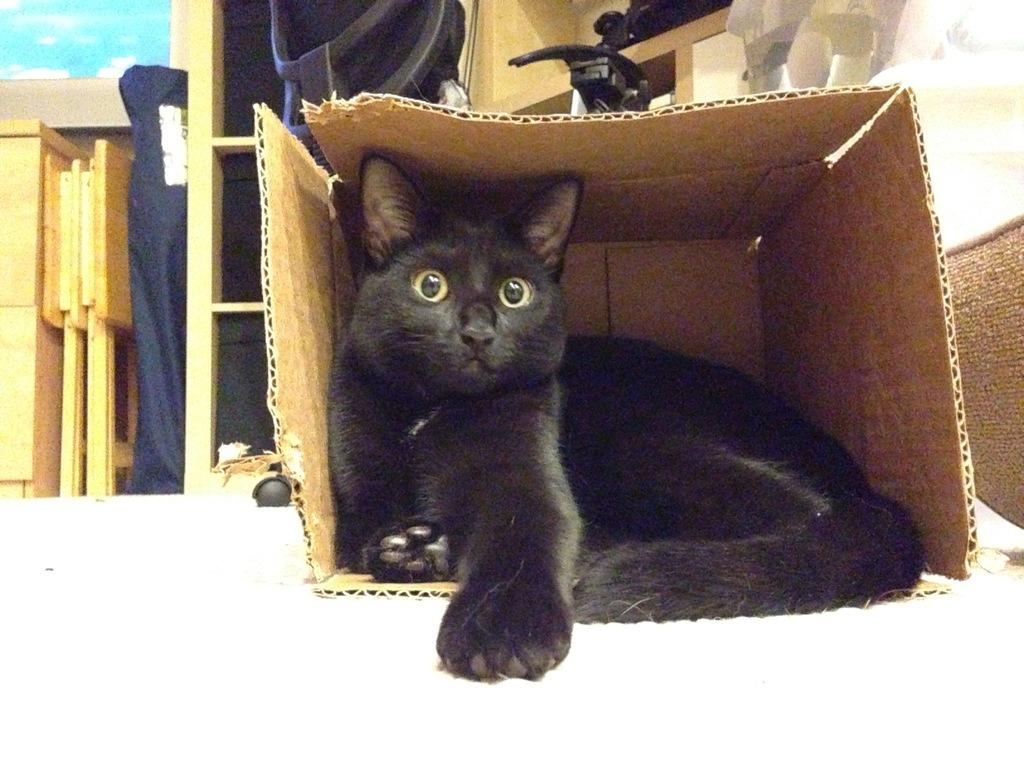What is the main object in the image? There is a cardboard box in the image. What is inside the cardboard box? A cat is sitting inside the box. What type of furniture can be seen behind the box? There are wooden cupboards behind the box. What is the other piece of furniture in the image? There is a wooden table in the image. What can be inferred about the contents of the cupboards? Objects are present in the cupboards. What type of committee is meeting in the image? There is no committee meeting in the image; it features a cardboard box with a cat inside and wooden furniture in the background. How many lizards can be seen crawling on the table in the image? There are no lizards present in the image; it only features a cat, a cardboard box, wooden cupboards, and a wooden table. 